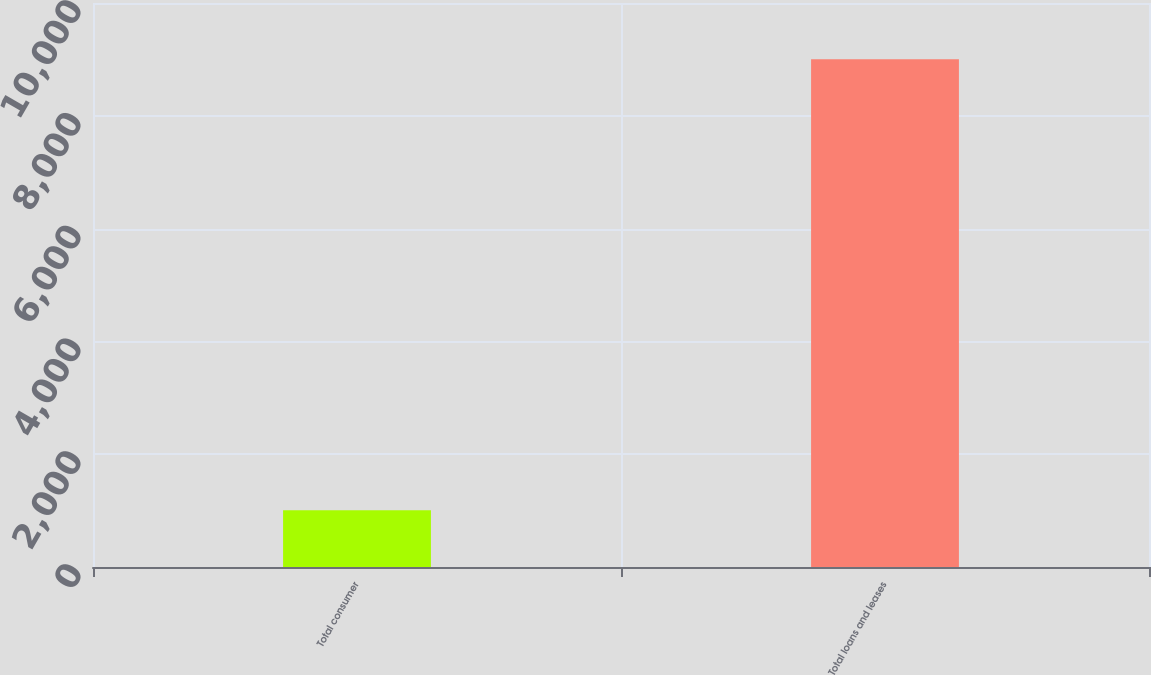Convert chart to OTSL. <chart><loc_0><loc_0><loc_500><loc_500><bar_chart><fcel>Total consumer<fcel>Total loans and leases<nl><fcel>1005<fcel>9002<nl></chart> 